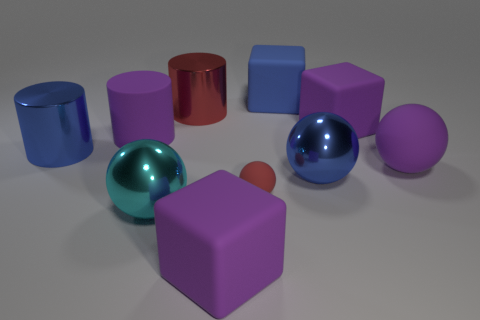Subtract all balls. How many objects are left? 6 Add 8 red spheres. How many red spheres exist? 9 Subtract 0 gray cubes. How many objects are left? 10 Subtract all small brown balls. Subtract all small matte things. How many objects are left? 9 Add 8 tiny rubber spheres. How many tiny rubber spheres are left? 9 